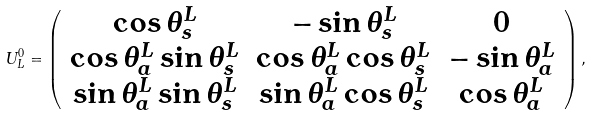Convert formula to latex. <formula><loc_0><loc_0><loc_500><loc_500>U _ { L } ^ { 0 } = \left ( \begin{array} { c c c } \cos \theta ^ { L } _ { s } & - \sin \theta ^ { L } _ { s } & 0 \\ \cos \theta ^ { L } _ { a } \sin \theta ^ { L } _ { s } & \cos \theta ^ { L } _ { a } \cos \theta ^ { L } _ { s } & - \sin \theta ^ { L } _ { a } \\ \sin \theta ^ { L } _ { a } \sin \theta ^ { L } _ { s } & \sin \theta ^ { L } _ { a } \cos \theta ^ { L } _ { s } & \cos \theta ^ { L } _ { a } \end{array} \right ) ,</formula> 